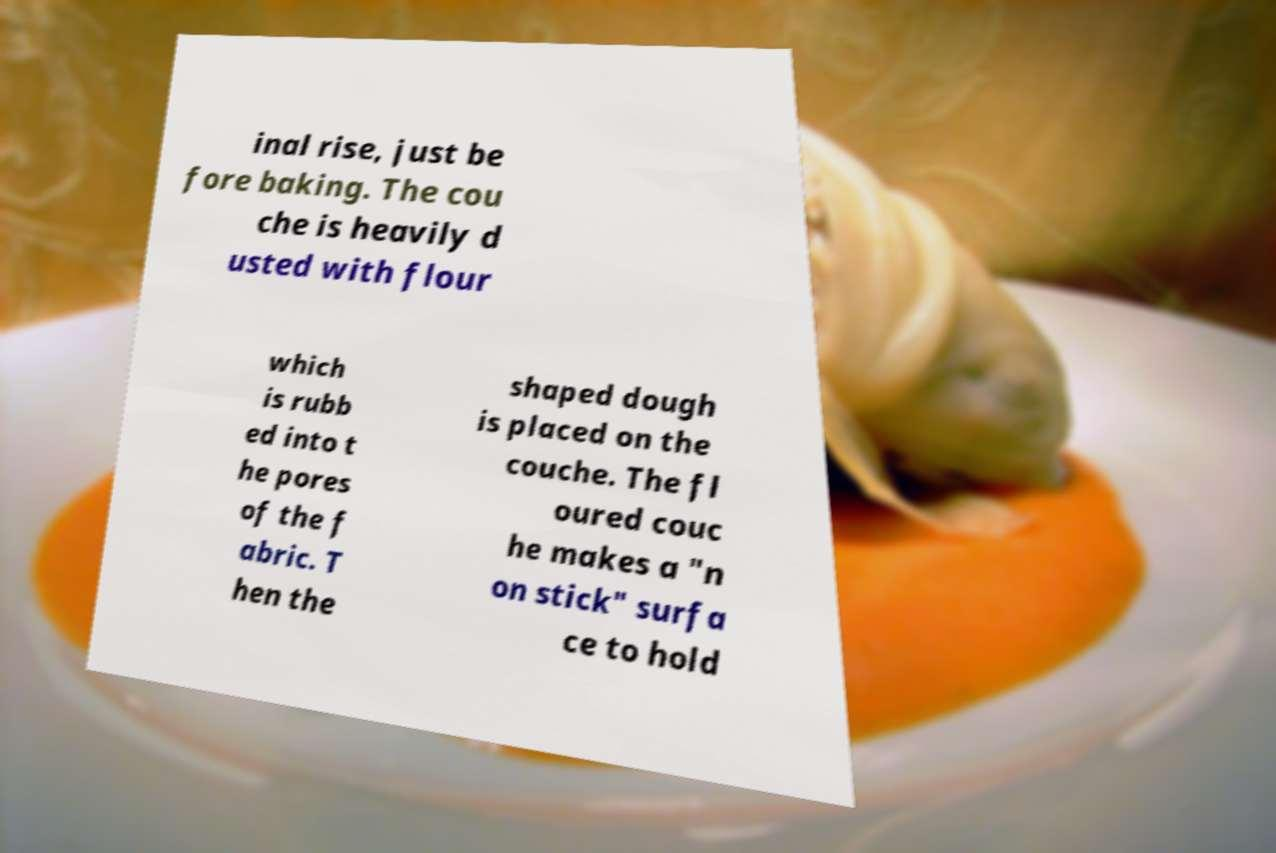For documentation purposes, I need the text within this image transcribed. Could you provide that? inal rise, just be fore baking. The cou che is heavily d usted with flour which is rubb ed into t he pores of the f abric. T hen the shaped dough is placed on the couche. The fl oured couc he makes a "n on stick" surfa ce to hold 